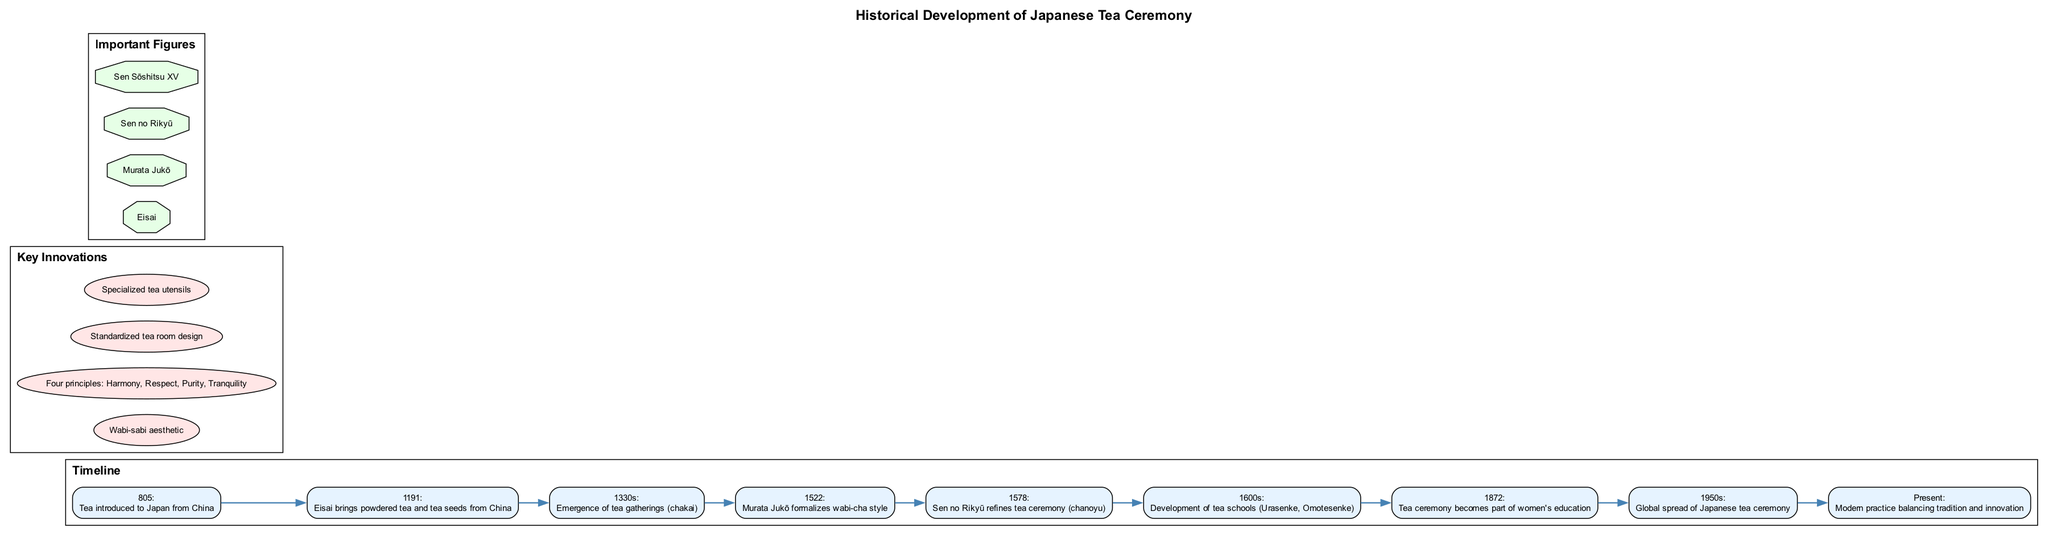What year was tea introduced to Japan from China? The timeline indicates the event of tea being introduced to Japan occurred in the year 805. This information is found at the start of the timeline.
Answer: 805 Who formalized the wabi-cha style? Referring to the timeline, the event listed for the year 1522 states that Murata Jukō formalized the wabi-cha style.
Answer: Murata Jukō Which two tea schools developed in the 1600s? The timeline mentions the development of tea schools and specifically includes Urasenke and Omotesenke under the 1600s section. This requires looking at the timeline entry for that time period.
Answer: Urasenke, Omotesenke List one of the four principles of the tea ceremony. The key innovations section indicates that one of the four principles is Harmony, Respect, Purity, or Tranquility. Since it specifically lists these principles, any one of them would be acceptable as an answer.
Answer: Harmony (or Respect, Purity, or Tranquility) What is a significant development in tea education mentioned in the timeline? According to the timeline, in 1872, the tea ceremony became part of women's education, marking this as a significant development in the history of the tea ceremony.
Answer: Women's education Who is recognized for refining the tea ceremony in 1578? Looking at the timeline, it states that Sen no Rikyū refined the tea ceremony in the year 1578, making him a key figure during that time in the evolution of the ceremony.
Answer: Sen no Rikyū How did the global spread of Japanese tea ceremony occur? The timeline notes that in the 1950s, there was a global spread of the Japanese tea ceremony. This indicates that during that decade, the practice began to reach broader international audiences.
Answer: 1950s What aesthetic is associated with the tea ceremony? The key innovations section includes the Wabi-sabi aesthetic, highlighting an important aspect of the tea ceremony that influences its visual and philosophical elements.
Answer: Wabi-sabi aesthetic 